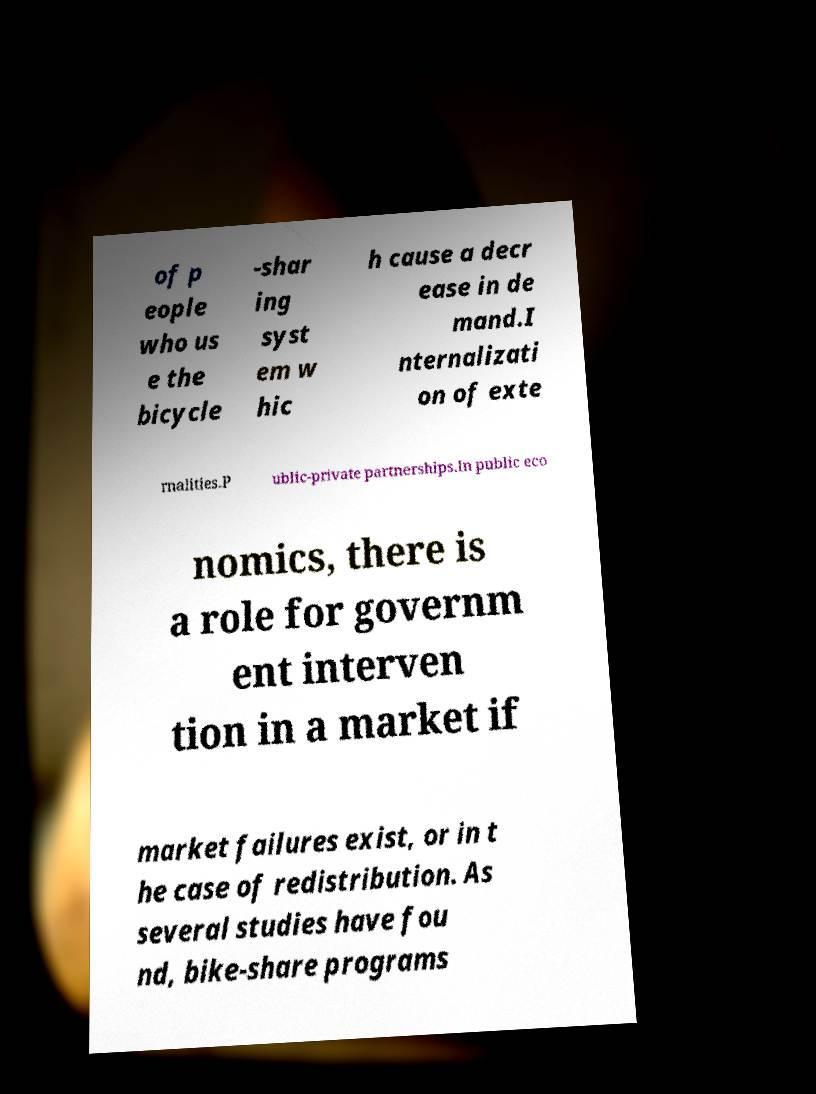Please read and relay the text visible in this image. What does it say? of p eople who us e the bicycle -shar ing syst em w hic h cause a decr ease in de mand.I nternalizati on of exte rnalities.P ublic-private partnerships.In public eco nomics, there is a role for governm ent interven tion in a market if market failures exist, or in t he case of redistribution. As several studies have fou nd, bike-share programs 